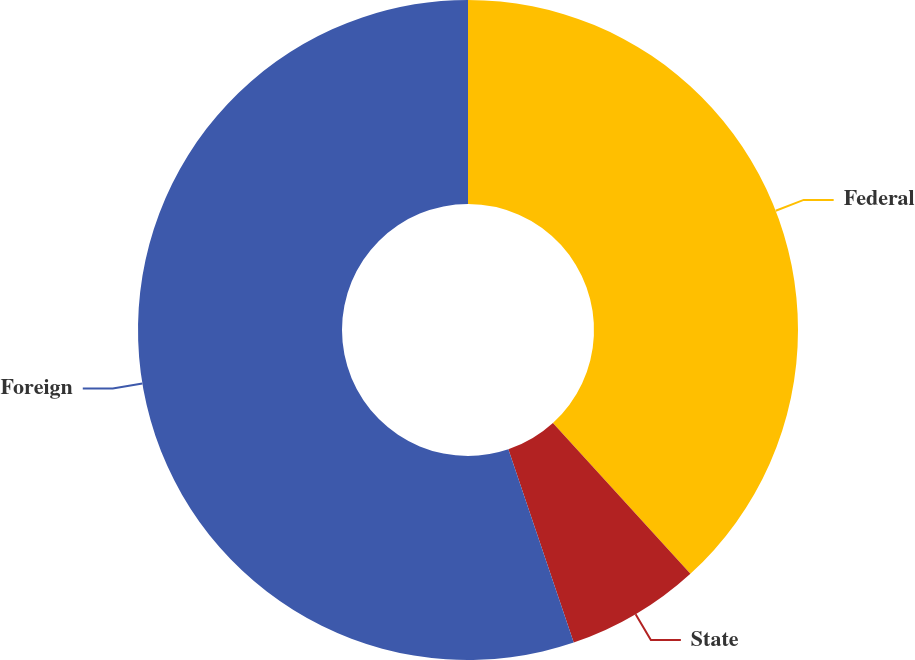<chart> <loc_0><loc_0><loc_500><loc_500><pie_chart><fcel>Federal<fcel>State<fcel>Foreign<nl><fcel>38.23%<fcel>6.58%<fcel>55.19%<nl></chart> 